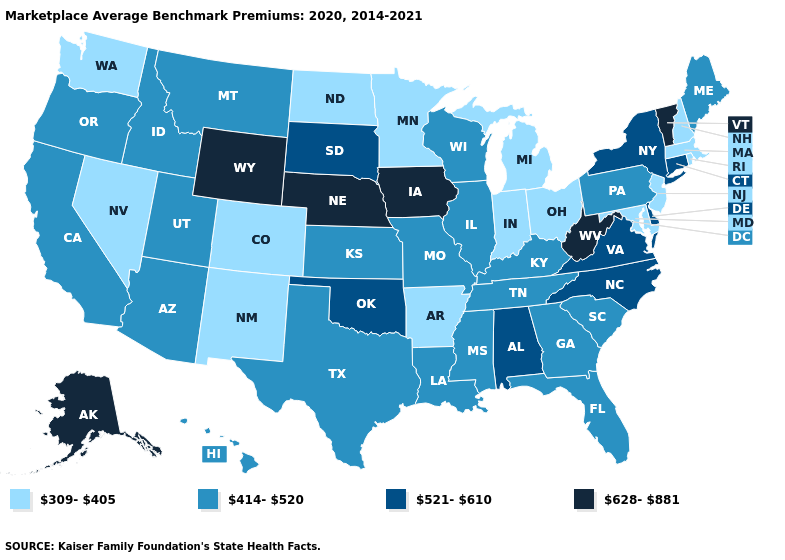What is the highest value in the MidWest ?
Write a very short answer. 628-881. Which states have the lowest value in the USA?
Answer briefly. Arkansas, Colorado, Indiana, Maryland, Massachusetts, Michigan, Minnesota, Nevada, New Hampshire, New Jersey, New Mexico, North Dakota, Ohio, Rhode Island, Washington. Name the states that have a value in the range 414-520?
Answer briefly. Arizona, California, Florida, Georgia, Hawaii, Idaho, Illinois, Kansas, Kentucky, Louisiana, Maine, Mississippi, Missouri, Montana, Oregon, Pennsylvania, South Carolina, Tennessee, Texas, Utah, Wisconsin. Among the states that border Minnesota , does Iowa have the lowest value?
Quick response, please. No. Name the states that have a value in the range 628-881?
Keep it brief. Alaska, Iowa, Nebraska, Vermont, West Virginia, Wyoming. Which states have the lowest value in the USA?
Answer briefly. Arkansas, Colorado, Indiana, Maryland, Massachusetts, Michigan, Minnesota, Nevada, New Hampshire, New Jersey, New Mexico, North Dakota, Ohio, Rhode Island, Washington. Name the states that have a value in the range 628-881?
Be succinct. Alaska, Iowa, Nebraska, Vermont, West Virginia, Wyoming. Name the states that have a value in the range 414-520?
Quick response, please. Arizona, California, Florida, Georgia, Hawaii, Idaho, Illinois, Kansas, Kentucky, Louisiana, Maine, Mississippi, Missouri, Montana, Oregon, Pennsylvania, South Carolina, Tennessee, Texas, Utah, Wisconsin. Among the states that border Virginia , which have the highest value?
Quick response, please. West Virginia. Does the map have missing data?
Be succinct. No. Among the states that border Ohio , does Indiana have the highest value?
Quick response, please. No. Which states hav the highest value in the Northeast?
Quick response, please. Vermont. How many symbols are there in the legend?
Quick response, please. 4. Which states have the highest value in the USA?
Keep it brief. Alaska, Iowa, Nebraska, Vermont, West Virginia, Wyoming. Does the first symbol in the legend represent the smallest category?
Concise answer only. Yes. 